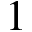<formula> <loc_0><loc_0><loc_500><loc_500>1</formula> 